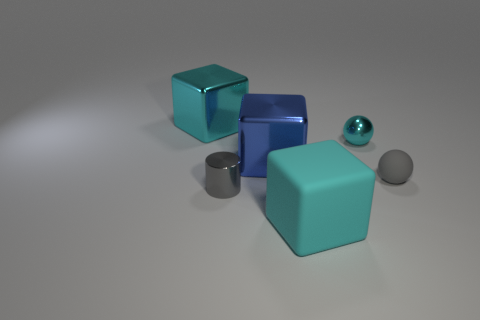Do the small metallic sphere and the small metal cylinder have the same color? No, they do not have the same color. The small metallic sphere appears to have a blue hue, while the small metal cylinder seems to have a silver or gray color. The lighting conditions and reflective properties of the materials also affect our perception of their colors. 